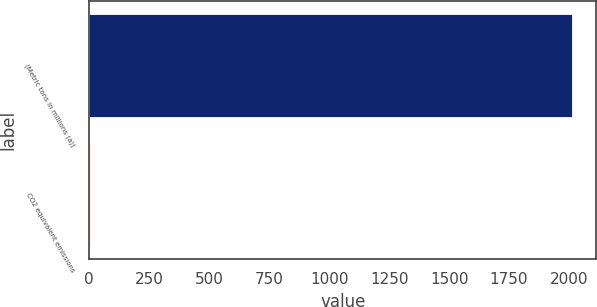Convert chart to OTSL. <chart><loc_0><loc_0><loc_500><loc_500><bar_chart><fcel>(Metric tons in millions (a))<fcel>CO2 equivalent emissions<nl><fcel>2013<fcel>3.4<nl></chart> 